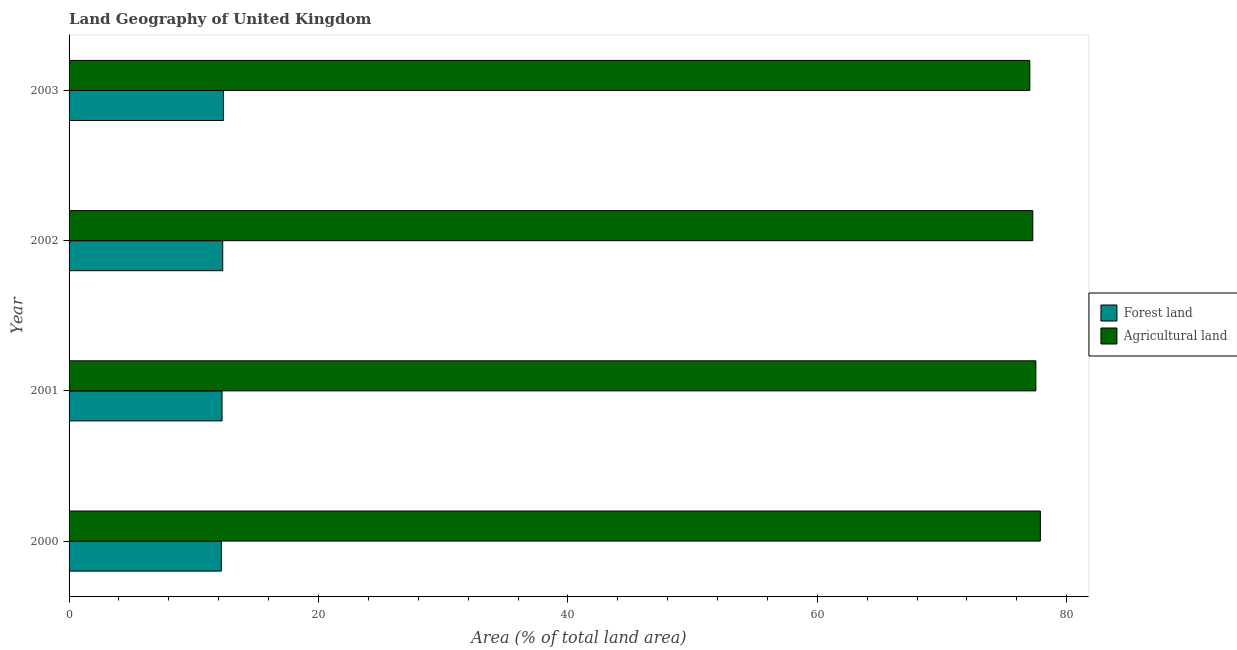Are the number of bars per tick equal to the number of legend labels?
Keep it short and to the point. Yes. In how many cases, is the number of bars for a given year not equal to the number of legend labels?
Your answer should be very brief. 0. What is the percentage of land area under forests in 2003?
Offer a very short reply. 12.38. Across all years, what is the maximum percentage of land area under forests?
Offer a very short reply. 12.38. Across all years, what is the minimum percentage of land area under forests?
Offer a very short reply. 12.21. What is the total percentage of land area under forests in the graph?
Offer a terse response. 49.17. What is the difference between the percentage of land area under forests in 2000 and that in 2001?
Give a very brief answer. -0.06. What is the difference between the percentage of land area under agriculture in 2000 and the percentage of land area under forests in 2001?
Offer a very short reply. 65.62. What is the average percentage of land area under forests per year?
Your response must be concise. 12.29. In the year 2001, what is the difference between the percentage of land area under agriculture and percentage of land area under forests?
Offer a very short reply. 65.26. What is the ratio of the percentage of land area under agriculture in 2000 to that in 2002?
Keep it short and to the point. 1.01. Is the difference between the percentage of land area under forests in 2002 and 2003 greater than the difference between the percentage of land area under agriculture in 2002 and 2003?
Give a very brief answer. No. What is the difference between the highest and the second highest percentage of land area under forests?
Provide a succinct answer. 0.06. What is the difference between the highest and the lowest percentage of land area under agriculture?
Keep it short and to the point. 0.85. Is the sum of the percentage of land area under agriculture in 2002 and 2003 greater than the maximum percentage of land area under forests across all years?
Make the answer very short. Yes. What does the 2nd bar from the top in 2000 represents?
Keep it short and to the point. Forest land. What does the 1st bar from the bottom in 2000 represents?
Keep it short and to the point. Forest land. How many bars are there?
Keep it short and to the point. 8. Are all the bars in the graph horizontal?
Make the answer very short. Yes. How many years are there in the graph?
Offer a very short reply. 4. What is the difference between two consecutive major ticks on the X-axis?
Make the answer very short. 20. Are the values on the major ticks of X-axis written in scientific E-notation?
Your answer should be very brief. No. Does the graph contain any zero values?
Keep it short and to the point. No. Where does the legend appear in the graph?
Give a very brief answer. Center right. How are the legend labels stacked?
Offer a terse response. Vertical. What is the title of the graph?
Your response must be concise. Land Geography of United Kingdom. What is the label or title of the X-axis?
Offer a terse response. Area (% of total land area). What is the Area (% of total land area) in Forest land in 2000?
Ensure brevity in your answer.  12.21. What is the Area (% of total land area) of Agricultural land in 2000?
Provide a short and direct response. 77.89. What is the Area (% of total land area) in Forest land in 2001?
Make the answer very short. 12.27. What is the Area (% of total land area) of Agricultural land in 2001?
Ensure brevity in your answer.  77.53. What is the Area (% of total land area) in Forest land in 2002?
Provide a short and direct response. 12.32. What is the Area (% of total land area) of Agricultural land in 2002?
Your response must be concise. 77.28. What is the Area (% of total land area) of Forest land in 2003?
Your answer should be very brief. 12.38. What is the Area (% of total land area) in Agricultural land in 2003?
Provide a succinct answer. 77.04. Across all years, what is the maximum Area (% of total land area) of Forest land?
Make the answer very short. 12.38. Across all years, what is the maximum Area (% of total land area) in Agricultural land?
Offer a terse response. 77.89. Across all years, what is the minimum Area (% of total land area) of Forest land?
Ensure brevity in your answer.  12.21. Across all years, what is the minimum Area (% of total land area) in Agricultural land?
Make the answer very short. 77.04. What is the total Area (% of total land area) of Forest land in the graph?
Provide a succinct answer. 49.17. What is the total Area (% of total land area) of Agricultural land in the graph?
Give a very brief answer. 309.73. What is the difference between the Area (% of total land area) of Forest land in 2000 and that in 2001?
Make the answer very short. -0.06. What is the difference between the Area (% of total land area) of Agricultural land in 2000 and that in 2001?
Give a very brief answer. 0.36. What is the difference between the Area (% of total land area) in Forest land in 2000 and that in 2002?
Provide a succinct answer. -0.11. What is the difference between the Area (% of total land area) of Agricultural land in 2000 and that in 2002?
Provide a succinct answer. 0.61. What is the difference between the Area (% of total land area) in Forest land in 2000 and that in 2003?
Provide a short and direct response. -0.17. What is the difference between the Area (% of total land area) in Agricultural land in 2000 and that in 2003?
Your answer should be very brief. 0.85. What is the difference between the Area (% of total land area) of Forest land in 2001 and that in 2002?
Ensure brevity in your answer.  -0.06. What is the difference between the Area (% of total land area) of Agricultural land in 2001 and that in 2002?
Offer a very short reply. 0.25. What is the difference between the Area (% of total land area) of Forest land in 2001 and that in 2003?
Provide a short and direct response. -0.11. What is the difference between the Area (% of total land area) of Agricultural land in 2001 and that in 2003?
Your response must be concise. 0.49. What is the difference between the Area (% of total land area) in Forest land in 2002 and that in 2003?
Offer a terse response. -0.06. What is the difference between the Area (% of total land area) in Agricultural land in 2002 and that in 2003?
Offer a terse response. 0.24. What is the difference between the Area (% of total land area) in Forest land in 2000 and the Area (% of total land area) in Agricultural land in 2001?
Make the answer very short. -65.32. What is the difference between the Area (% of total land area) of Forest land in 2000 and the Area (% of total land area) of Agricultural land in 2002?
Provide a succinct answer. -65.07. What is the difference between the Area (% of total land area) of Forest land in 2000 and the Area (% of total land area) of Agricultural land in 2003?
Your answer should be compact. -64.83. What is the difference between the Area (% of total land area) in Forest land in 2001 and the Area (% of total land area) in Agricultural land in 2002?
Offer a terse response. -65.01. What is the difference between the Area (% of total land area) in Forest land in 2001 and the Area (% of total land area) in Agricultural land in 2003?
Provide a succinct answer. -64.77. What is the difference between the Area (% of total land area) in Forest land in 2002 and the Area (% of total land area) in Agricultural land in 2003?
Make the answer very short. -64.72. What is the average Area (% of total land area) of Forest land per year?
Offer a terse response. 12.29. What is the average Area (% of total land area) of Agricultural land per year?
Ensure brevity in your answer.  77.43. In the year 2000, what is the difference between the Area (% of total land area) of Forest land and Area (% of total land area) of Agricultural land?
Offer a very short reply. -65.68. In the year 2001, what is the difference between the Area (% of total land area) in Forest land and Area (% of total land area) in Agricultural land?
Make the answer very short. -65.26. In the year 2002, what is the difference between the Area (% of total land area) in Forest land and Area (% of total land area) in Agricultural land?
Your answer should be compact. -64.96. In the year 2003, what is the difference between the Area (% of total land area) in Forest land and Area (% of total land area) in Agricultural land?
Your answer should be very brief. -64.66. What is the ratio of the Area (% of total land area) of Agricultural land in 2000 to that in 2002?
Provide a short and direct response. 1.01. What is the ratio of the Area (% of total land area) of Forest land in 2000 to that in 2003?
Give a very brief answer. 0.99. What is the ratio of the Area (% of total land area) of Forest land in 2001 to that in 2003?
Give a very brief answer. 0.99. What is the ratio of the Area (% of total land area) in Forest land in 2002 to that in 2003?
Make the answer very short. 1. What is the difference between the highest and the second highest Area (% of total land area) in Forest land?
Your answer should be very brief. 0.06. What is the difference between the highest and the second highest Area (% of total land area) of Agricultural land?
Your response must be concise. 0.36. What is the difference between the highest and the lowest Area (% of total land area) in Forest land?
Ensure brevity in your answer.  0.17. What is the difference between the highest and the lowest Area (% of total land area) of Agricultural land?
Give a very brief answer. 0.85. 